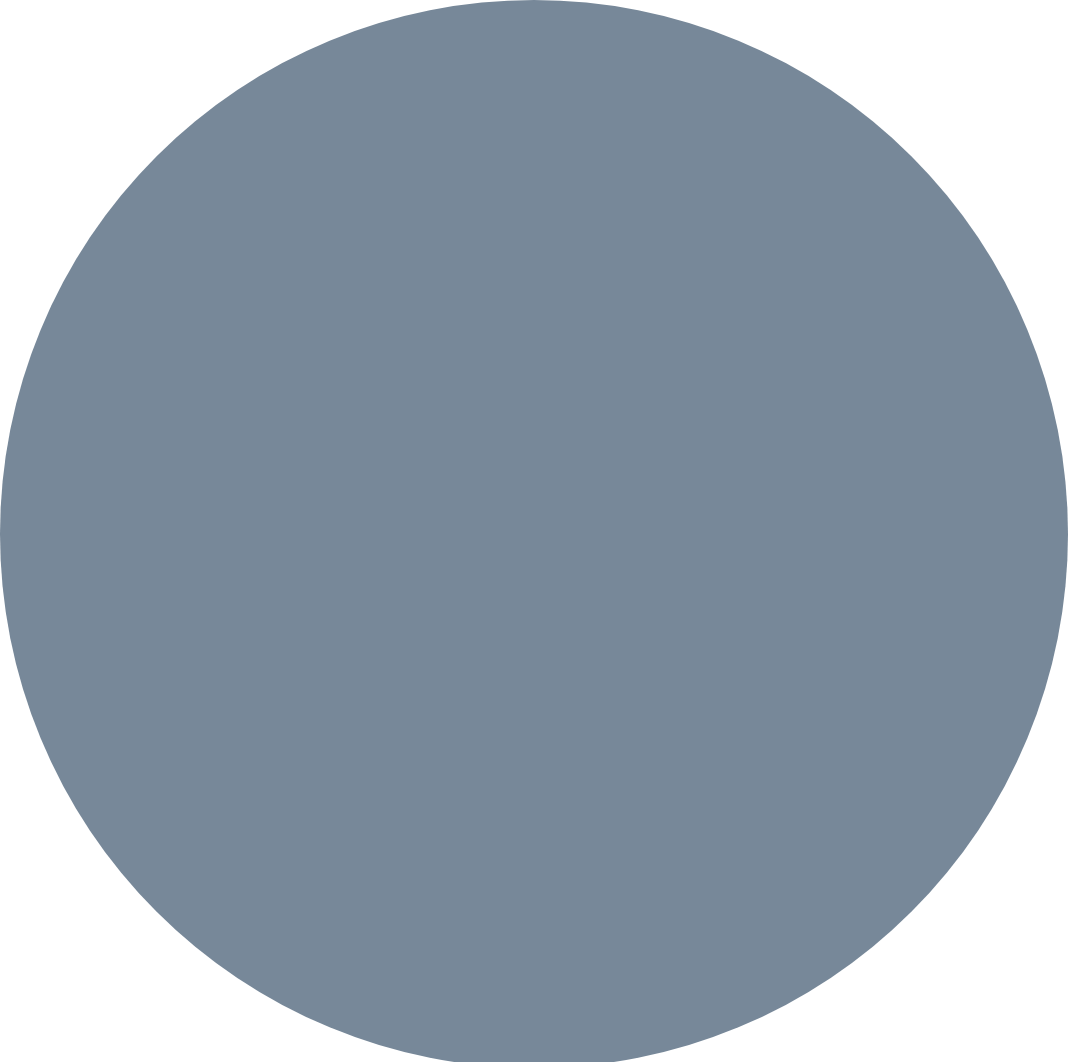Convert chart to OTSL. <chart><loc_0><loc_0><loc_500><loc_500><pie_chart><fcel>For the three months ended<nl><fcel>100.0%<nl></chart> 